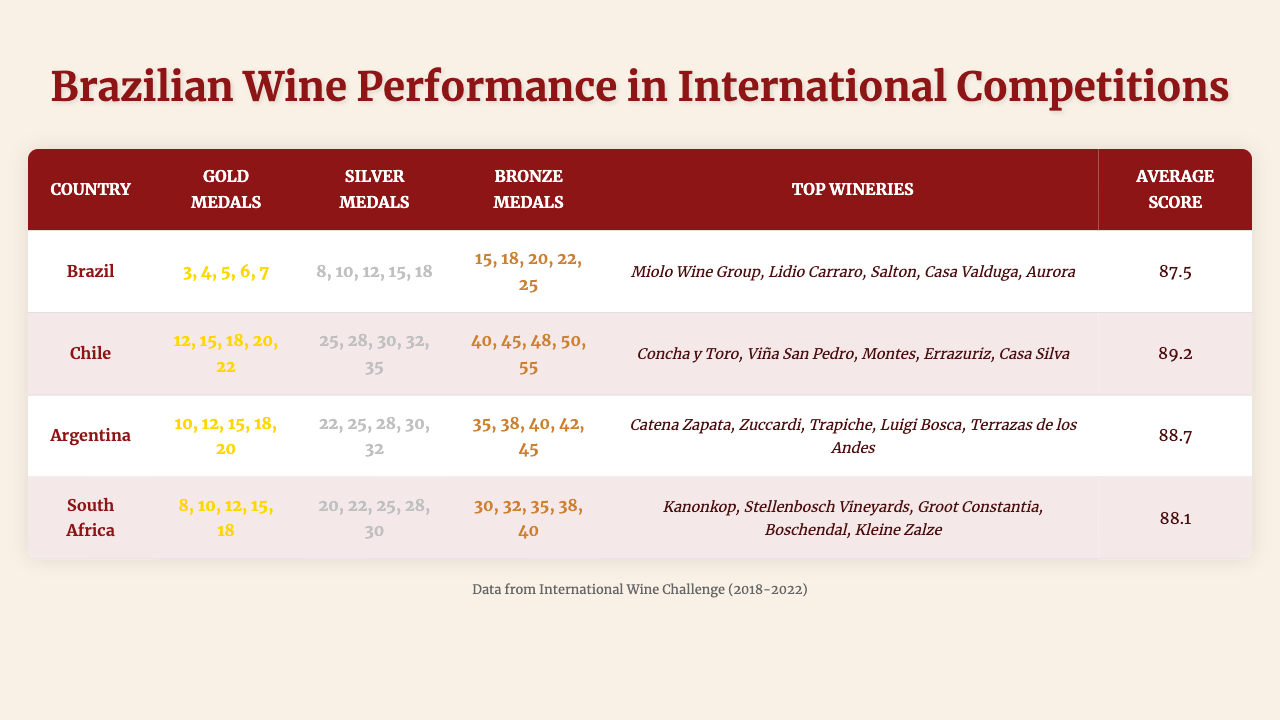What country has the highest number of gold medals in 2022? According to the table, Brazil earned the highest number of gold medals in 2022 with a total of 7.
Answer: Brazil How many total silver medals did Argentina win from 2018 to 2022? Adding the silver medals from each year for Argentina: 22 + 25 + 28 + 30 + 32 = 137.
Answer: 137 Which country has the lowest average score? The average scores for each country are as follows: Brazil (87.5), Chile (89.2), Argentina (88.7), South Africa (88.1). Brazil has the lowest average score at 87.5.
Answer: Brazil What is the total number of bronze medals earned by South Africa in 2021 and 2022? For South Africa, the bronze medals in 2021 and 2022 are 38 and 40, respectively. Adding those gives us 38 + 40 = 78.
Answer: 78 True or False: Brazil has more gold medals than Argentina in 2020. In 2020, Brazil won 5 gold medals while Argentina won 15. Therefore, it's false that Brazil has more gold medals than Argentina.
Answer: False Which country experienced the most significant increase in gold medals from 2018 to 2022? Analyzing the data, Brazil increased from 3 gold medals in 2018 to 7 in 2022, for a total increase of 4. Chile increased from 12 to 22, which is a total increase of 10. Thus, Chile had the most significant increase.
Answer: Chile What is the average number of bronze medals awarded to all countries over the five years? Adding the bronze medals for all countries across the five years: Brazil (15+18+20+22+25=100), Chile (40+45+48+50+55=238), Argentina (35+38+40+42+45=200), South Africa (30+32+35+38+40=175). The total is 100 + 238 + 200 + 175 = 713. Dividing by the number of countries (4) gives us an average of 713 / 4 = 178.25.
Answer: 178.25 Which Brazilian wine region is listed among the top wineries for the gold medal winners? The data does not specify a direct correlation to gold medals, but Brazil's top wineries are: Miolo Wine Group, Lidio Carraro, Salton, Casa Valduga, and Aurora, all originating from regions like Serra Gaúcha and Vale dos Vinhedos, which are part of Brazilian wine culture.
Answer: Yes, regions like Serra Gaúcha and Vale dos Vinhedos are related In 2021, which country had more silver medals, Argentina or Brazil? In 2021, Brazil won 15 silver medals, while Argentina won 30. Since 30 is greater than 15, Argentina had more silver medals.
Answer: Argentina 